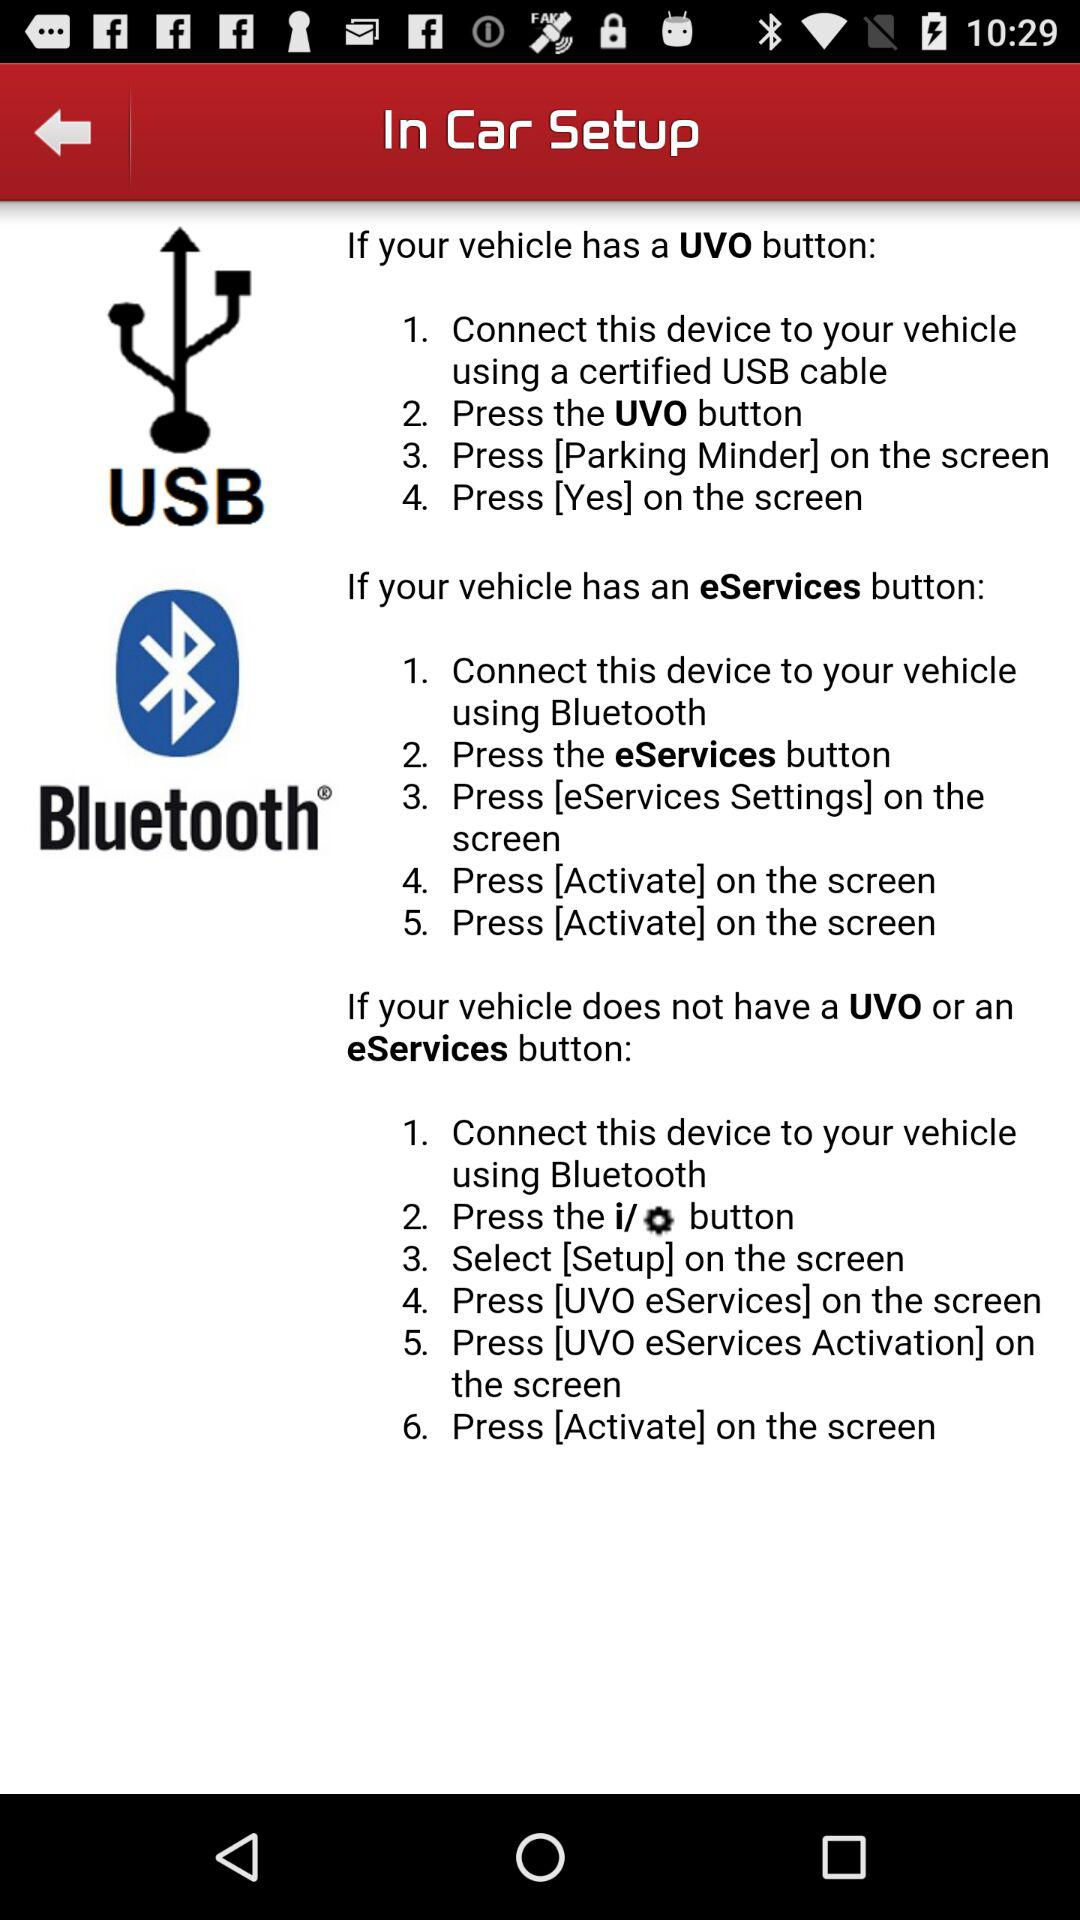How do I connect if my vehicle has a UVO button? If your vehicle has a UVO button, connect the device to your vehicle using a certified USB cable, press the UVO button, press [Parking Minder] on the screen and press [Yes] on the screen. 